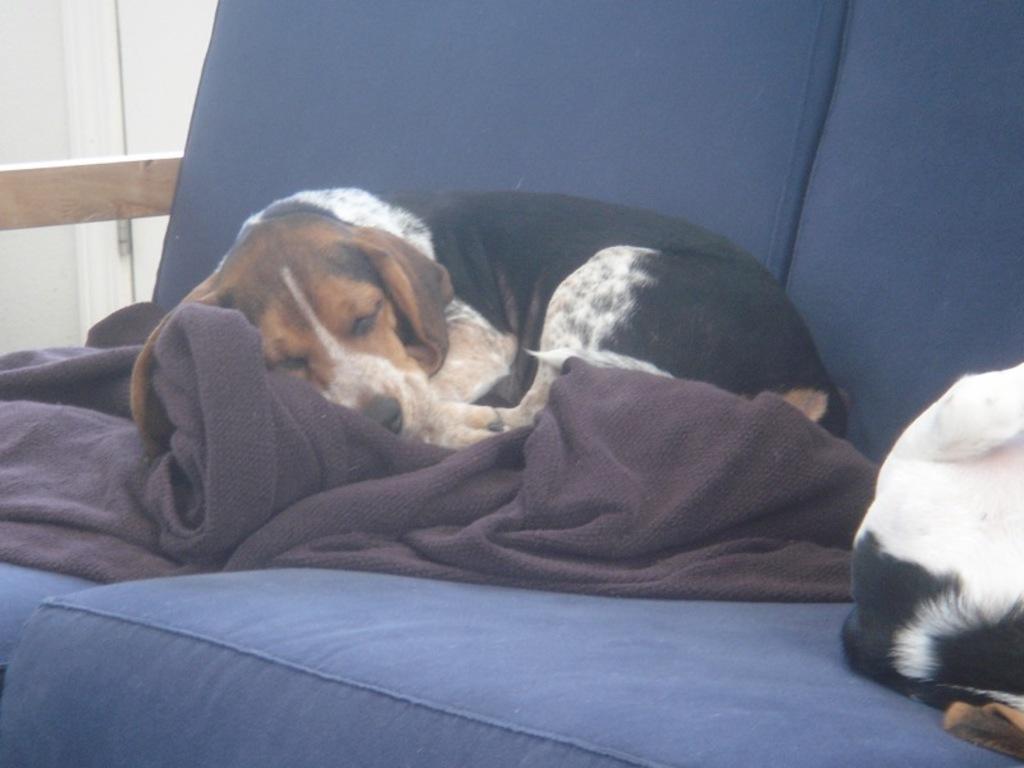Could you give a brief overview of what you see in this image? In this image we can see a sofa with a blanket. On that there is a dog. On the right side there is another animal on the sofa. 